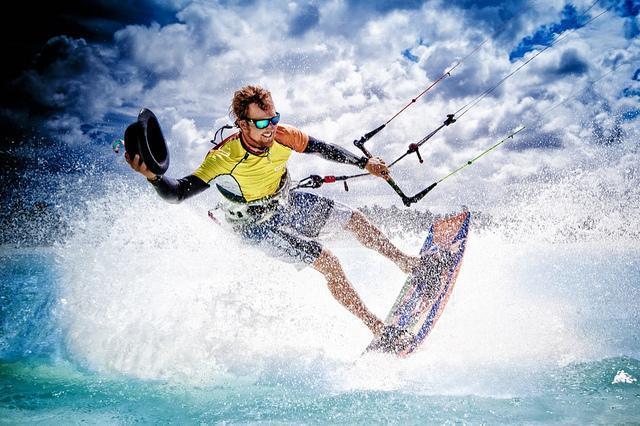How many of the fruit that can be seen in the bowl are bananas?
Give a very brief answer. 0. 